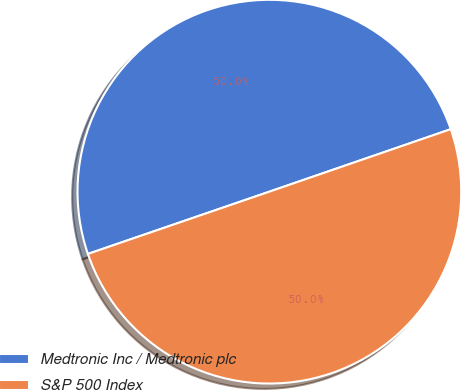Convert chart to OTSL. <chart><loc_0><loc_0><loc_500><loc_500><pie_chart><fcel>Medtronic Inc / Medtronic plc<fcel>S&P 500 Index<nl><fcel>49.98%<fcel>50.02%<nl></chart> 